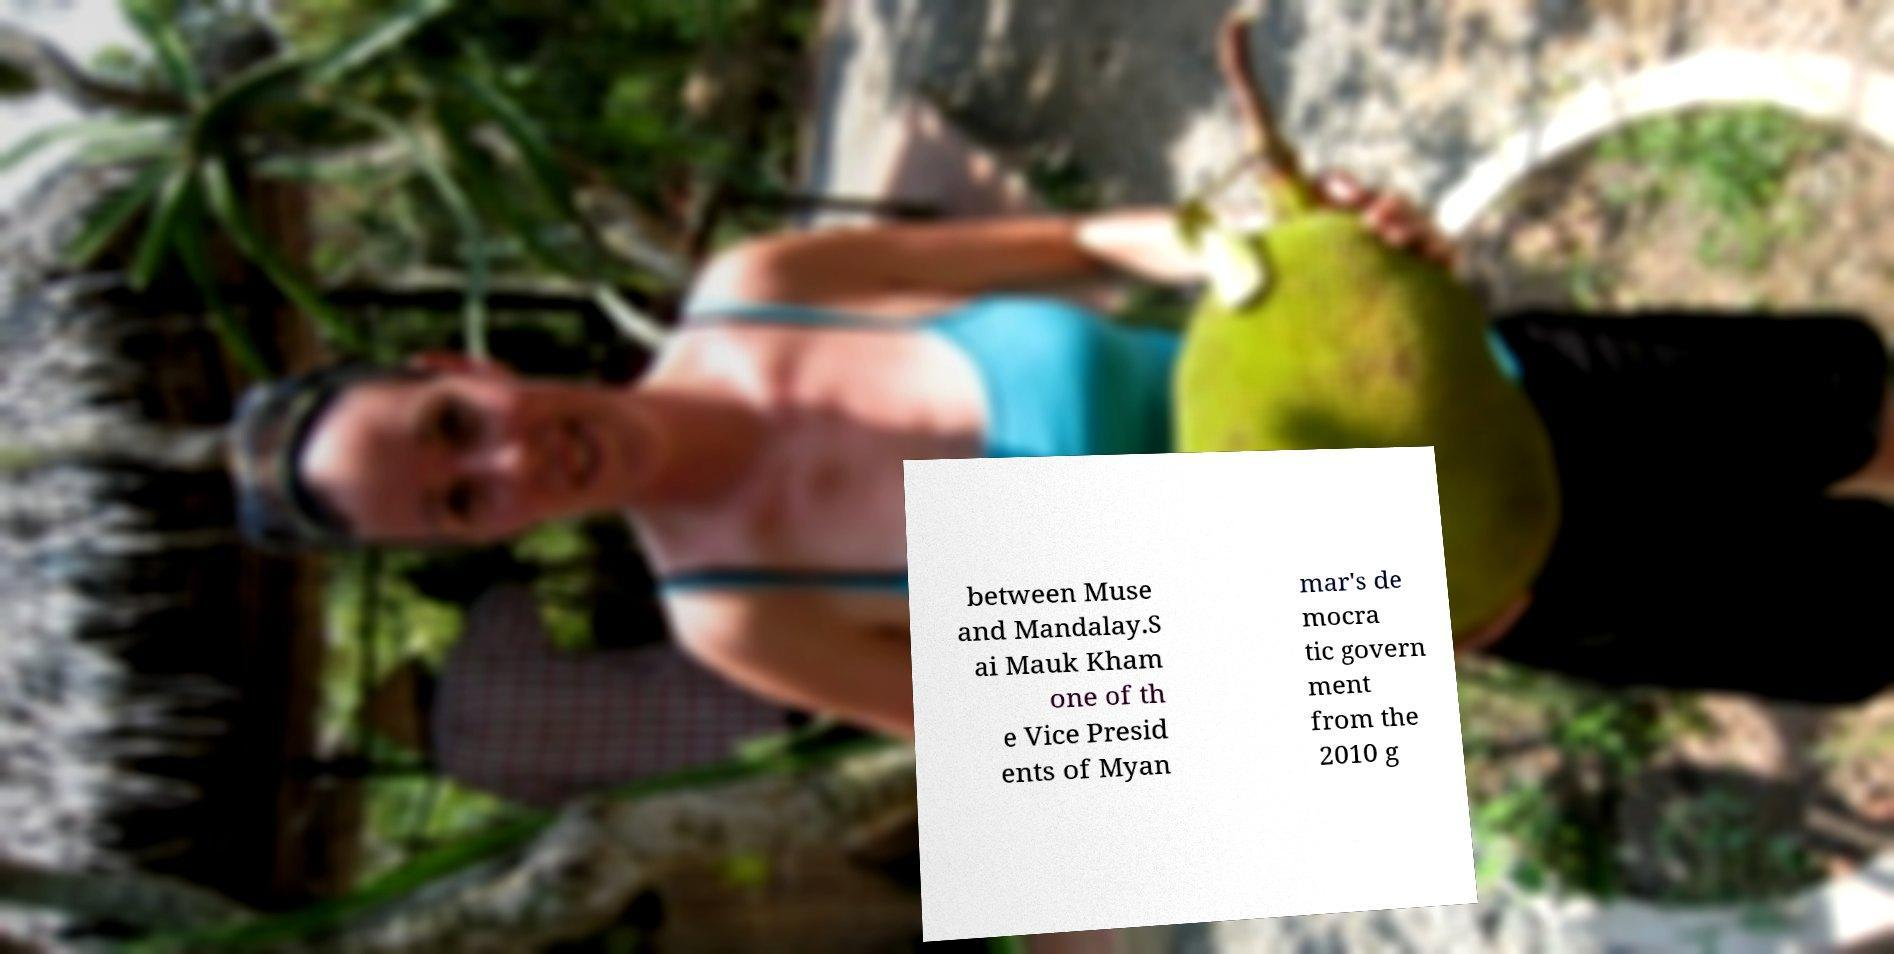What messages or text are displayed in this image? I need them in a readable, typed format. between Muse and Mandalay.S ai Mauk Kham one of th e Vice Presid ents of Myan mar's de mocra tic govern ment from the 2010 g 